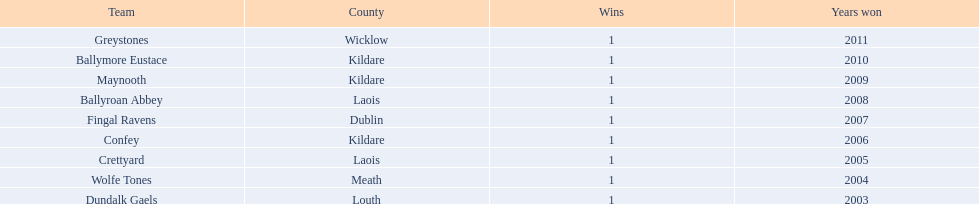What's the geographical position of ballymore eustace? Kildare. What other teams come from kildare besides ballymore eustace? Maynooth, Confey. Who was the winner in the 2009 game between maynooth and confey? Maynooth. 